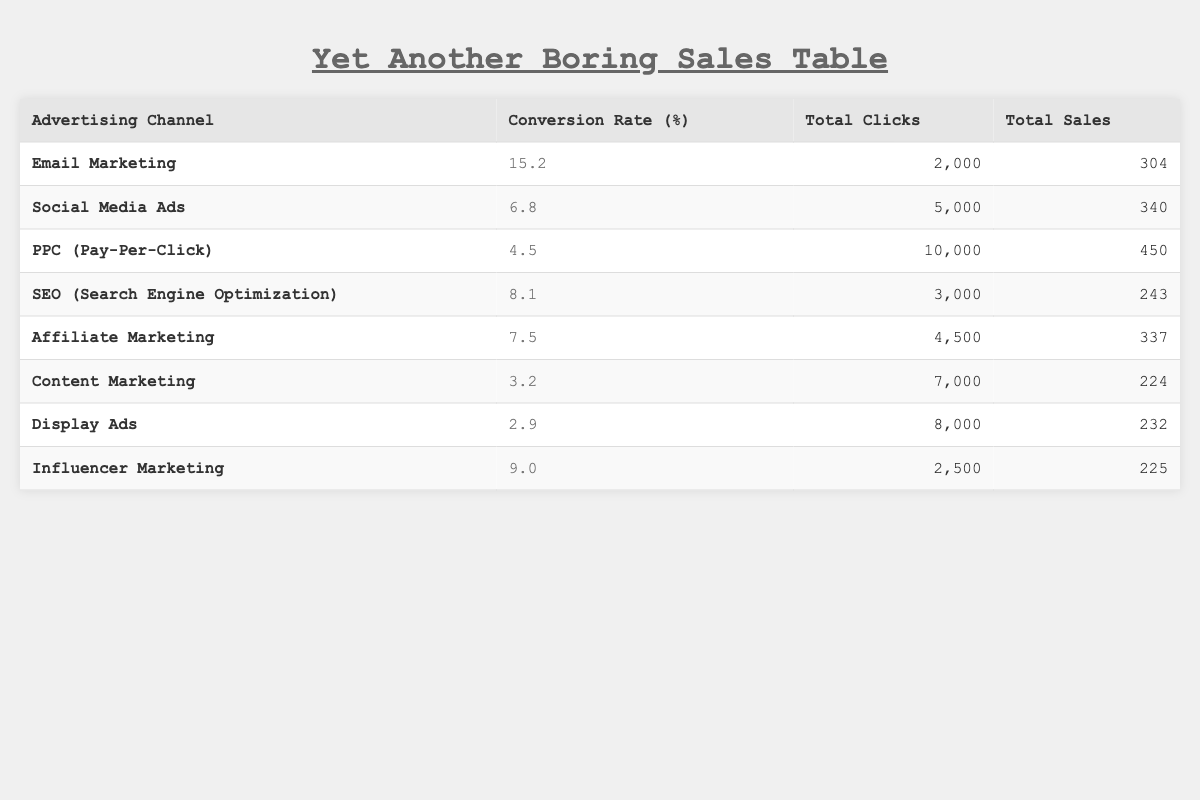What's the highest conversion rate among the advertising channels? The conversion rates listed are: 15.2 for Email Marketing, 6.8 for Social Media Ads, 4.5 for PPC, 8.1 for SEO, 7.5 for Affiliate Marketing, 3.2 for Content Marketing, 2.9 for Display Ads, and 9.0 for Influencer Marketing. The highest rate is 15.2 for Email Marketing.
Answer: 15.2 How many total clicks did Social Media Ads receive? The total clicks for Social Media Ads are directly listed in the table as 5000.
Answer: 5000 What is the total number of sales from all advertising channels? By summing the total sales from each channel: 304 + 340 + 450 + 243 + 337 + 224 + 232 + 225 = 1865.
Answer: 1865 Is the conversion rate for Display Ads higher than that of Influencer Marketing? The conversion rate for Display Ads is 2.9, whereas for Influencer Marketing it is 9.0. Since 2.9 is not greater than 9.0, the statement is false.
Answer: No What percentage of total clicks was achieved by Email Marketing? Total clicks from Email Marketing are 2000. The overall total clicks across all channels is: 2000 + 5000 + 10000 + 3000 + 4500 + 7000 + 8000 + 2500 = 35,000. The percentage for Email Marketing is (2000/35000) * 100, which equals approximately 5.71%.
Answer: 5.71 Which advertising channel had the lowest total sales? Reviewing the total sales, Content Marketing has the lowest value at 224.
Answer: 224 What is the average conversion rate of all the advertising channels? The conversion rates are: 15.2, 6.8, 4.5, 8.1, 7.5, 3.2, 2.9, and 9.0. To calculate the average, sum them: 15.2 + 6.8 + 4.5 + 8.1 + 7.5 + 3.2 + 2.9 + 9.0 = 57.2. There are 8 channels, so the average is 57.2 / 8 = 7.15.
Answer: 7.15 Which channel had more total clicks, PPC or SEO? PPC had 10,000 total clicks, while SEO had 3000. Since 10,000 is greater than 3000, PPC had more clicks.
Answer: PPC What’s the difference in conversion rates between Email Marketing and Affiliate Marketing? The conversion rate for Email Marketing is 15.2, and for Affiliate Marketing, it is 7.5. The difference is 15.2 - 7.5 = 7.7.
Answer: 7.7 